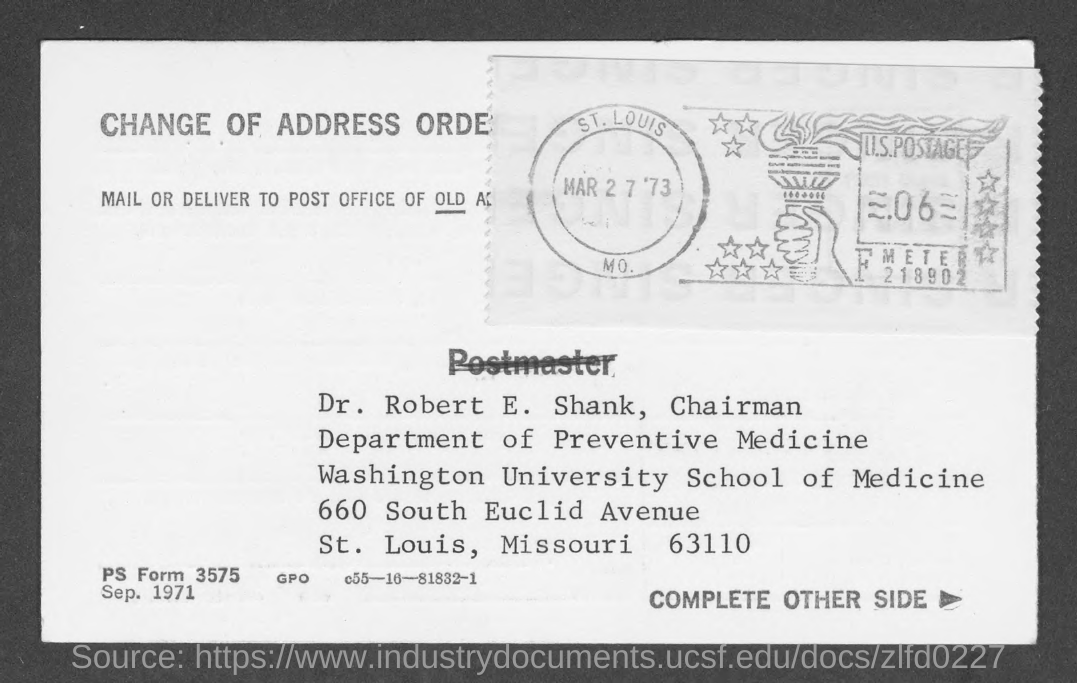Draw attention to some important aspects in this diagram. The given page mentions a date of March 27, 1973. Dr. Robert E. Shank holds the designation of Chairman. The given page mentions Washington University. The Department of Preventive Medicine is a department mentioned in the given page. The name mentioned in the given form is Dr. Robert E. Shank. 